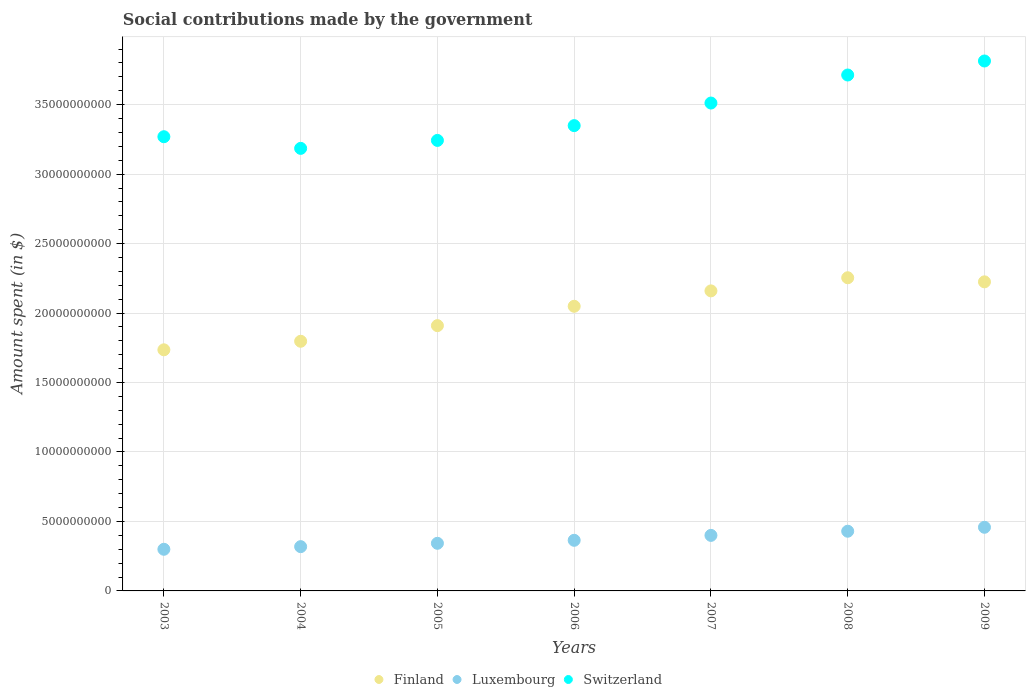What is the amount spent on social contributions in Finland in 2008?
Keep it short and to the point. 2.25e+1. Across all years, what is the maximum amount spent on social contributions in Luxembourg?
Make the answer very short. 4.58e+09. Across all years, what is the minimum amount spent on social contributions in Luxembourg?
Give a very brief answer. 3.00e+09. In which year was the amount spent on social contributions in Switzerland minimum?
Keep it short and to the point. 2004. What is the total amount spent on social contributions in Luxembourg in the graph?
Provide a succinct answer. 2.61e+1. What is the difference between the amount spent on social contributions in Luxembourg in 2004 and that in 2005?
Ensure brevity in your answer.  -2.41e+08. What is the difference between the amount spent on social contributions in Switzerland in 2005 and the amount spent on social contributions in Luxembourg in 2007?
Make the answer very short. 2.84e+1. What is the average amount spent on social contributions in Finland per year?
Your answer should be very brief. 2.02e+1. In the year 2009, what is the difference between the amount spent on social contributions in Switzerland and amount spent on social contributions in Luxembourg?
Provide a short and direct response. 3.36e+1. What is the ratio of the amount spent on social contributions in Switzerland in 2003 to that in 2008?
Keep it short and to the point. 0.88. What is the difference between the highest and the second highest amount spent on social contributions in Luxembourg?
Offer a very short reply. 2.83e+08. What is the difference between the highest and the lowest amount spent on social contributions in Luxembourg?
Make the answer very short. 1.58e+09. In how many years, is the amount spent on social contributions in Finland greater than the average amount spent on social contributions in Finland taken over all years?
Your answer should be very brief. 4. Does the amount spent on social contributions in Finland monotonically increase over the years?
Your response must be concise. No. How many dotlines are there?
Your answer should be compact. 3. What is the difference between two consecutive major ticks on the Y-axis?
Offer a terse response. 5.00e+09. Are the values on the major ticks of Y-axis written in scientific E-notation?
Keep it short and to the point. No. Does the graph contain any zero values?
Give a very brief answer. No. Where does the legend appear in the graph?
Offer a very short reply. Bottom center. How many legend labels are there?
Provide a short and direct response. 3. What is the title of the graph?
Your response must be concise. Social contributions made by the government. Does "Libya" appear as one of the legend labels in the graph?
Make the answer very short. No. What is the label or title of the X-axis?
Your response must be concise. Years. What is the label or title of the Y-axis?
Offer a terse response. Amount spent (in $). What is the Amount spent (in $) in Finland in 2003?
Your response must be concise. 1.74e+1. What is the Amount spent (in $) in Luxembourg in 2003?
Offer a terse response. 3.00e+09. What is the Amount spent (in $) of Switzerland in 2003?
Offer a terse response. 3.27e+1. What is the Amount spent (in $) of Finland in 2004?
Ensure brevity in your answer.  1.80e+1. What is the Amount spent (in $) of Luxembourg in 2004?
Provide a succinct answer. 3.19e+09. What is the Amount spent (in $) of Switzerland in 2004?
Provide a succinct answer. 3.19e+1. What is the Amount spent (in $) in Finland in 2005?
Make the answer very short. 1.91e+1. What is the Amount spent (in $) of Luxembourg in 2005?
Your answer should be very brief. 3.43e+09. What is the Amount spent (in $) of Switzerland in 2005?
Your answer should be compact. 3.24e+1. What is the Amount spent (in $) in Finland in 2006?
Your answer should be very brief. 2.05e+1. What is the Amount spent (in $) of Luxembourg in 2006?
Give a very brief answer. 3.64e+09. What is the Amount spent (in $) in Switzerland in 2006?
Offer a very short reply. 3.35e+1. What is the Amount spent (in $) of Finland in 2007?
Ensure brevity in your answer.  2.16e+1. What is the Amount spent (in $) of Luxembourg in 2007?
Ensure brevity in your answer.  4.00e+09. What is the Amount spent (in $) in Switzerland in 2007?
Ensure brevity in your answer.  3.51e+1. What is the Amount spent (in $) of Finland in 2008?
Provide a short and direct response. 2.25e+1. What is the Amount spent (in $) of Luxembourg in 2008?
Provide a succinct answer. 4.30e+09. What is the Amount spent (in $) in Switzerland in 2008?
Make the answer very short. 3.71e+1. What is the Amount spent (in $) in Finland in 2009?
Your response must be concise. 2.22e+1. What is the Amount spent (in $) of Luxembourg in 2009?
Provide a short and direct response. 4.58e+09. What is the Amount spent (in $) in Switzerland in 2009?
Your response must be concise. 3.81e+1. Across all years, what is the maximum Amount spent (in $) in Finland?
Offer a terse response. 2.25e+1. Across all years, what is the maximum Amount spent (in $) of Luxembourg?
Keep it short and to the point. 4.58e+09. Across all years, what is the maximum Amount spent (in $) of Switzerland?
Offer a terse response. 3.81e+1. Across all years, what is the minimum Amount spent (in $) in Finland?
Provide a short and direct response. 1.74e+1. Across all years, what is the minimum Amount spent (in $) of Luxembourg?
Offer a very short reply. 3.00e+09. Across all years, what is the minimum Amount spent (in $) of Switzerland?
Offer a very short reply. 3.19e+1. What is the total Amount spent (in $) of Finland in the graph?
Keep it short and to the point. 1.41e+11. What is the total Amount spent (in $) in Luxembourg in the graph?
Keep it short and to the point. 2.61e+1. What is the total Amount spent (in $) of Switzerland in the graph?
Give a very brief answer. 2.41e+11. What is the difference between the Amount spent (in $) in Finland in 2003 and that in 2004?
Offer a terse response. -6.15e+08. What is the difference between the Amount spent (in $) in Luxembourg in 2003 and that in 2004?
Your response must be concise. -1.89e+08. What is the difference between the Amount spent (in $) of Switzerland in 2003 and that in 2004?
Your response must be concise. 8.39e+08. What is the difference between the Amount spent (in $) of Finland in 2003 and that in 2005?
Your answer should be very brief. -1.74e+09. What is the difference between the Amount spent (in $) in Luxembourg in 2003 and that in 2005?
Offer a terse response. -4.31e+08. What is the difference between the Amount spent (in $) of Switzerland in 2003 and that in 2005?
Provide a short and direct response. 2.66e+08. What is the difference between the Amount spent (in $) of Finland in 2003 and that in 2006?
Your answer should be very brief. -3.13e+09. What is the difference between the Amount spent (in $) in Luxembourg in 2003 and that in 2006?
Provide a succinct answer. -6.46e+08. What is the difference between the Amount spent (in $) of Switzerland in 2003 and that in 2006?
Provide a succinct answer. -7.99e+08. What is the difference between the Amount spent (in $) in Finland in 2003 and that in 2007?
Make the answer very short. -4.24e+09. What is the difference between the Amount spent (in $) in Luxembourg in 2003 and that in 2007?
Your answer should be compact. -1.00e+09. What is the difference between the Amount spent (in $) in Switzerland in 2003 and that in 2007?
Provide a succinct answer. -2.42e+09. What is the difference between the Amount spent (in $) in Finland in 2003 and that in 2008?
Offer a very short reply. -5.19e+09. What is the difference between the Amount spent (in $) in Luxembourg in 2003 and that in 2008?
Make the answer very short. -1.30e+09. What is the difference between the Amount spent (in $) of Switzerland in 2003 and that in 2008?
Your answer should be very brief. -4.44e+09. What is the difference between the Amount spent (in $) in Finland in 2003 and that in 2009?
Keep it short and to the point. -4.89e+09. What is the difference between the Amount spent (in $) of Luxembourg in 2003 and that in 2009?
Provide a succinct answer. -1.58e+09. What is the difference between the Amount spent (in $) in Switzerland in 2003 and that in 2009?
Give a very brief answer. -5.45e+09. What is the difference between the Amount spent (in $) in Finland in 2004 and that in 2005?
Provide a short and direct response. -1.12e+09. What is the difference between the Amount spent (in $) in Luxembourg in 2004 and that in 2005?
Make the answer very short. -2.41e+08. What is the difference between the Amount spent (in $) in Switzerland in 2004 and that in 2005?
Give a very brief answer. -5.73e+08. What is the difference between the Amount spent (in $) of Finland in 2004 and that in 2006?
Keep it short and to the point. -2.52e+09. What is the difference between the Amount spent (in $) of Luxembourg in 2004 and that in 2006?
Keep it short and to the point. -4.57e+08. What is the difference between the Amount spent (in $) of Switzerland in 2004 and that in 2006?
Offer a very short reply. -1.64e+09. What is the difference between the Amount spent (in $) in Finland in 2004 and that in 2007?
Offer a terse response. -3.63e+09. What is the difference between the Amount spent (in $) in Luxembourg in 2004 and that in 2007?
Your answer should be very brief. -8.11e+08. What is the difference between the Amount spent (in $) of Switzerland in 2004 and that in 2007?
Offer a very short reply. -3.26e+09. What is the difference between the Amount spent (in $) of Finland in 2004 and that in 2008?
Provide a succinct answer. -4.57e+09. What is the difference between the Amount spent (in $) of Luxembourg in 2004 and that in 2008?
Offer a very short reply. -1.11e+09. What is the difference between the Amount spent (in $) of Switzerland in 2004 and that in 2008?
Your answer should be very brief. -5.28e+09. What is the difference between the Amount spent (in $) of Finland in 2004 and that in 2009?
Your answer should be compact. -4.28e+09. What is the difference between the Amount spent (in $) of Luxembourg in 2004 and that in 2009?
Your answer should be compact. -1.39e+09. What is the difference between the Amount spent (in $) of Switzerland in 2004 and that in 2009?
Make the answer very short. -6.29e+09. What is the difference between the Amount spent (in $) of Finland in 2005 and that in 2006?
Make the answer very short. -1.39e+09. What is the difference between the Amount spent (in $) in Luxembourg in 2005 and that in 2006?
Your answer should be very brief. -2.16e+08. What is the difference between the Amount spent (in $) in Switzerland in 2005 and that in 2006?
Give a very brief answer. -1.06e+09. What is the difference between the Amount spent (in $) of Finland in 2005 and that in 2007?
Offer a very short reply. -2.50e+09. What is the difference between the Amount spent (in $) of Luxembourg in 2005 and that in 2007?
Your response must be concise. -5.70e+08. What is the difference between the Amount spent (in $) in Switzerland in 2005 and that in 2007?
Offer a terse response. -2.69e+09. What is the difference between the Amount spent (in $) of Finland in 2005 and that in 2008?
Your answer should be very brief. -3.45e+09. What is the difference between the Amount spent (in $) of Luxembourg in 2005 and that in 2008?
Your answer should be compact. -8.69e+08. What is the difference between the Amount spent (in $) in Switzerland in 2005 and that in 2008?
Your answer should be very brief. -4.71e+09. What is the difference between the Amount spent (in $) of Finland in 2005 and that in 2009?
Provide a succinct answer. -3.15e+09. What is the difference between the Amount spent (in $) in Luxembourg in 2005 and that in 2009?
Provide a short and direct response. -1.15e+09. What is the difference between the Amount spent (in $) in Switzerland in 2005 and that in 2009?
Ensure brevity in your answer.  -5.72e+09. What is the difference between the Amount spent (in $) in Finland in 2006 and that in 2007?
Provide a short and direct response. -1.11e+09. What is the difference between the Amount spent (in $) of Luxembourg in 2006 and that in 2007?
Provide a succinct answer. -3.54e+08. What is the difference between the Amount spent (in $) in Switzerland in 2006 and that in 2007?
Offer a terse response. -1.62e+09. What is the difference between the Amount spent (in $) in Finland in 2006 and that in 2008?
Make the answer very short. -2.05e+09. What is the difference between the Amount spent (in $) of Luxembourg in 2006 and that in 2008?
Your response must be concise. -6.53e+08. What is the difference between the Amount spent (in $) of Switzerland in 2006 and that in 2008?
Make the answer very short. -3.64e+09. What is the difference between the Amount spent (in $) of Finland in 2006 and that in 2009?
Provide a succinct answer. -1.76e+09. What is the difference between the Amount spent (in $) of Luxembourg in 2006 and that in 2009?
Ensure brevity in your answer.  -9.37e+08. What is the difference between the Amount spent (in $) in Switzerland in 2006 and that in 2009?
Offer a terse response. -4.65e+09. What is the difference between the Amount spent (in $) in Finland in 2007 and that in 2008?
Offer a terse response. -9.45e+08. What is the difference between the Amount spent (in $) of Luxembourg in 2007 and that in 2008?
Offer a very short reply. -2.99e+08. What is the difference between the Amount spent (in $) in Switzerland in 2007 and that in 2008?
Offer a very short reply. -2.02e+09. What is the difference between the Amount spent (in $) in Finland in 2007 and that in 2009?
Offer a very short reply. -6.51e+08. What is the difference between the Amount spent (in $) of Luxembourg in 2007 and that in 2009?
Provide a succinct answer. -5.83e+08. What is the difference between the Amount spent (in $) of Switzerland in 2007 and that in 2009?
Provide a short and direct response. -3.03e+09. What is the difference between the Amount spent (in $) in Finland in 2008 and that in 2009?
Your answer should be very brief. 2.94e+08. What is the difference between the Amount spent (in $) of Luxembourg in 2008 and that in 2009?
Provide a succinct answer. -2.83e+08. What is the difference between the Amount spent (in $) in Switzerland in 2008 and that in 2009?
Offer a very short reply. -1.01e+09. What is the difference between the Amount spent (in $) in Finland in 2003 and the Amount spent (in $) in Luxembourg in 2004?
Provide a short and direct response. 1.42e+1. What is the difference between the Amount spent (in $) in Finland in 2003 and the Amount spent (in $) in Switzerland in 2004?
Offer a terse response. -1.45e+1. What is the difference between the Amount spent (in $) in Luxembourg in 2003 and the Amount spent (in $) in Switzerland in 2004?
Offer a very short reply. -2.89e+1. What is the difference between the Amount spent (in $) of Finland in 2003 and the Amount spent (in $) of Luxembourg in 2005?
Make the answer very short. 1.39e+1. What is the difference between the Amount spent (in $) of Finland in 2003 and the Amount spent (in $) of Switzerland in 2005?
Your answer should be very brief. -1.51e+1. What is the difference between the Amount spent (in $) of Luxembourg in 2003 and the Amount spent (in $) of Switzerland in 2005?
Your response must be concise. -2.94e+1. What is the difference between the Amount spent (in $) in Finland in 2003 and the Amount spent (in $) in Luxembourg in 2006?
Your answer should be compact. 1.37e+1. What is the difference between the Amount spent (in $) in Finland in 2003 and the Amount spent (in $) in Switzerland in 2006?
Make the answer very short. -1.61e+1. What is the difference between the Amount spent (in $) in Luxembourg in 2003 and the Amount spent (in $) in Switzerland in 2006?
Your answer should be compact. -3.05e+1. What is the difference between the Amount spent (in $) in Finland in 2003 and the Amount spent (in $) in Luxembourg in 2007?
Provide a succinct answer. 1.34e+1. What is the difference between the Amount spent (in $) of Finland in 2003 and the Amount spent (in $) of Switzerland in 2007?
Give a very brief answer. -1.78e+1. What is the difference between the Amount spent (in $) in Luxembourg in 2003 and the Amount spent (in $) in Switzerland in 2007?
Provide a succinct answer. -3.21e+1. What is the difference between the Amount spent (in $) of Finland in 2003 and the Amount spent (in $) of Luxembourg in 2008?
Give a very brief answer. 1.31e+1. What is the difference between the Amount spent (in $) in Finland in 2003 and the Amount spent (in $) in Switzerland in 2008?
Offer a very short reply. -1.98e+1. What is the difference between the Amount spent (in $) of Luxembourg in 2003 and the Amount spent (in $) of Switzerland in 2008?
Provide a succinct answer. -3.41e+1. What is the difference between the Amount spent (in $) of Finland in 2003 and the Amount spent (in $) of Luxembourg in 2009?
Give a very brief answer. 1.28e+1. What is the difference between the Amount spent (in $) in Finland in 2003 and the Amount spent (in $) in Switzerland in 2009?
Make the answer very short. -2.08e+1. What is the difference between the Amount spent (in $) in Luxembourg in 2003 and the Amount spent (in $) in Switzerland in 2009?
Offer a very short reply. -3.51e+1. What is the difference between the Amount spent (in $) in Finland in 2004 and the Amount spent (in $) in Luxembourg in 2005?
Offer a very short reply. 1.45e+1. What is the difference between the Amount spent (in $) in Finland in 2004 and the Amount spent (in $) in Switzerland in 2005?
Make the answer very short. -1.45e+1. What is the difference between the Amount spent (in $) in Luxembourg in 2004 and the Amount spent (in $) in Switzerland in 2005?
Give a very brief answer. -2.92e+1. What is the difference between the Amount spent (in $) in Finland in 2004 and the Amount spent (in $) in Luxembourg in 2006?
Give a very brief answer. 1.43e+1. What is the difference between the Amount spent (in $) of Finland in 2004 and the Amount spent (in $) of Switzerland in 2006?
Offer a terse response. -1.55e+1. What is the difference between the Amount spent (in $) in Luxembourg in 2004 and the Amount spent (in $) in Switzerland in 2006?
Your answer should be compact. -3.03e+1. What is the difference between the Amount spent (in $) of Finland in 2004 and the Amount spent (in $) of Luxembourg in 2007?
Keep it short and to the point. 1.40e+1. What is the difference between the Amount spent (in $) in Finland in 2004 and the Amount spent (in $) in Switzerland in 2007?
Keep it short and to the point. -1.71e+1. What is the difference between the Amount spent (in $) in Luxembourg in 2004 and the Amount spent (in $) in Switzerland in 2007?
Provide a short and direct response. -3.19e+1. What is the difference between the Amount spent (in $) in Finland in 2004 and the Amount spent (in $) in Luxembourg in 2008?
Your response must be concise. 1.37e+1. What is the difference between the Amount spent (in $) in Finland in 2004 and the Amount spent (in $) in Switzerland in 2008?
Offer a very short reply. -1.92e+1. What is the difference between the Amount spent (in $) in Luxembourg in 2004 and the Amount spent (in $) in Switzerland in 2008?
Your answer should be compact. -3.39e+1. What is the difference between the Amount spent (in $) in Finland in 2004 and the Amount spent (in $) in Luxembourg in 2009?
Provide a short and direct response. 1.34e+1. What is the difference between the Amount spent (in $) in Finland in 2004 and the Amount spent (in $) in Switzerland in 2009?
Your answer should be very brief. -2.02e+1. What is the difference between the Amount spent (in $) of Luxembourg in 2004 and the Amount spent (in $) of Switzerland in 2009?
Provide a succinct answer. -3.50e+1. What is the difference between the Amount spent (in $) of Finland in 2005 and the Amount spent (in $) of Luxembourg in 2006?
Keep it short and to the point. 1.55e+1. What is the difference between the Amount spent (in $) in Finland in 2005 and the Amount spent (in $) in Switzerland in 2006?
Make the answer very short. -1.44e+1. What is the difference between the Amount spent (in $) of Luxembourg in 2005 and the Amount spent (in $) of Switzerland in 2006?
Your response must be concise. -3.01e+1. What is the difference between the Amount spent (in $) in Finland in 2005 and the Amount spent (in $) in Luxembourg in 2007?
Your answer should be compact. 1.51e+1. What is the difference between the Amount spent (in $) in Finland in 2005 and the Amount spent (in $) in Switzerland in 2007?
Your answer should be very brief. -1.60e+1. What is the difference between the Amount spent (in $) of Luxembourg in 2005 and the Amount spent (in $) of Switzerland in 2007?
Provide a succinct answer. -3.17e+1. What is the difference between the Amount spent (in $) in Finland in 2005 and the Amount spent (in $) in Luxembourg in 2008?
Keep it short and to the point. 1.48e+1. What is the difference between the Amount spent (in $) in Finland in 2005 and the Amount spent (in $) in Switzerland in 2008?
Provide a short and direct response. -1.80e+1. What is the difference between the Amount spent (in $) of Luxembourg in 2005 and the Amount spent (in $) of Switzerland in 2008?
Your answer should be very brief. -3.37e+1. What is the difference between the Amount spent (in $) in Finland in 2005 and the Amount spent (in $) in Luxembourg in 2009?
Your response must be concise. 1.45e+1. What is the difference between the Amount spent (in $) of Finland in 2005 and the Amount spent (in $) of Switzerland in 2009?
Keep it short and to the point. -1.90e+1. What is the difference between the Amount spent (in $) of Luxembourg in 2005 and the Amount spent (in $) of Switzerland in 2009?
Keep it short and to the point. -3.47e+1. What is the difference between the Amount spent (in $) in Finland in 2006 and the Amount spent (in $) in Luxembourg in 2007?
Offer a very short reply. 1.65e+1. What is the difference between the Amount spent (in $) of Finland in 2006 and the Amount spent (in $) of Switzerland in 2007?
Your answer should be very brief. -1.46e+1. What is the difference between the Amount spent (in $) of Luxembourg in 2006 and the Amount spent (in $) of Switzerland in 2007?
Ensure brevity in your answer.  -3.15e+1. What is the difference between the Amount spent (in $) of Finland in 2006 and the Amount spent (in $) of Luxembourg in 2008?
Give a very brief answer. 1.62e+1. What is the difference between the Amount spent (in $) in Finland in 2006 and the Amount spent (in $) in Switzerland in 2008?
Your answer should be compact. -1.66e+1. What is the difference between the Amount spent (in $) of Luxembourg in 2006 and the Amount spent (in $) of Switzerland in 2008?
Offer a terse response. -3.35e+1. What is the difference between the Amount spent (in $) of Finland in 2006 and the Amount spent (in $) of Luxembourg in 2009?
Give a very brief answer. 1.59e+1. What is the difference between the Amount spent (in $) of Finland in 2006 and the Amount spent (in $) of Switzerland in 2009?
Provide a short and direct response. -1.77e+1. What is the difference between the Amount spent (in $) of Luxembourg in 2006 and the Amount spent (in $) of Switzerland in 2009?
Give a very brief answer. -3.45e+1. What is the difference between the Amount spent (in $) of Finland in 2007 and the Amount spent (in $) of Luxembourg in 2008?
Your response must be concise. 1.73e+1. What is the difference between the Amount spent (in $) in Finland in 2007 and the Amount spent (in $) in Switzerland in 2008?
Offer a very short reply. -1.55e+1. What is the difference between the Amount spent (in $) in Luxembourg in 2007 and the Amount spent (in $) in Switzerland in 2008?
Keep it short and to the point. -3.31e+1. What is the difference between the Amount spent (in $) of Finland in 2007 and the Amount spent (in $) of Luxembourg in 2009?
Offer a very short reply. 1.70e+1. What is the difference between the Amount spent (in $) of Finland in 2007 and the Amount spent (in $) of Switzerland in 2009?
Your response must be concise. -1.65e+1. What is the difference between the Amount spent (in $) of Luxembourg in 2007 and the Amount spent (in $) of Switzerland in 2009?
Give a very brief answer. -3.41e+1. What is the difference between the Amount spent (in $) in Finland in 2008 and the Amount spent (in $) in Luxembourg in 2009?
Your answer should be compact. 1.80e+1. What is the difference between the Amount spent (in $) in Finland in 2008 and the Amount spent (in $) in Switzerland in 2009?
Provide a succinct answer. -1.56e+1. What is the difference between the Amount spent (in $) in Luxembourg in 2008 and the Amount spent (in $) in Switzerland in 2009?
Provide a short and direct response. -3.38e+1. What is the average Amount spent (in $) in Finland per year?
Make the answer very short. 2.02e+1. What is the average Amount spent (in $) of Luxembourg per year?
Provide a succinct answer. 3.73e+09. What is the average Amount spent (in $) of Switzerland per year?
Provide a short and direct response. 3.44e+1. In the year 2003, what is the difference between the Amount spent (in $) of Finland and Amount spent (in $) of Luxembourg?
Offer a very short reply. 1.44e+1. In the year 2003, what is the difference between the Amount spent (in $) of Finland and Amount spent (in $) of Switzerland?
Your answer should be very brief. -1.53e+1. In the year 2003, what is the difference between the Amount spent (in $) in Luxembourg and Amount spent (in $) in Switzerland?
Give a very brief answer. -2.97e+1. In the year 2004, what is the difference between the Amount spent (in $) of Finland and Amount spent (in $) of Luxembourg?
Offer a very short reply. 1.48e+1. In the year 2004, what is the difference between the Amount spent (in $) in Finland and Amount spent (in $) in Switzerland?
Make the answer very short. -1.39e+1. In the year 2004, what is the difference between the Amount spent (in $) in Luxembourg and Amount spent (in $) in Switzerland?
Keep it short and to the point. -2.87e+1. In the year 2005, what is the difference between the Amount spent (in $) of Finland and Amount spent (in $) of Luxembourg?
Keep it short and to the point. 1.57e+1. In the year 2005, what is the difference between the Amount spent (in $) of Finland and Amount spent (in $) of Switzerland?
Your answer should be very brief. -1.33e+1. In the year 2005, what is the difference between the Amount spent (in $) of Luxembourg and Amount spent (in $) of Switzerland?
Your answer should be very brief. -2.90e+1. In the year 2006, what is the difference between the Amount spent (in $) in Finland and Amount spent (in $) in Luxembourg?
Provide a succinct answer. 1.68e+1. In the year 2006, what is the difference between the Amount spent (in $) of Finland and Amount spent (in $) of Switzerland?
Offer a terse response. -1.30e+1. In the year 2006, what is the difference between the Amount spent (in $) in Luxembourg and Amount spent (in $) in Switzerland?
Make the answer very short. -2.98e+1. In the year 2007, what is the difference between the Amount spent (in $) of Finland and Amount spent (in $) of Luxembourg?
Provide a short and direct response. 1.76e+1. In the year 2007, what is the difference between the Amount spent (in $) of Finland and Amount spent (in $) of Switzerland?
Ensure brevity in your answer.  -1.35e+1. In the year 2007, what is the difference between the Amount spent (in $) of Luxembourg and Amount spent (in $) of Switzerland?
Ensure brevity in your answer.  -3.11e+1. In the year 2008, what is the difference between the Amount spent (in $) in Finland and Amount spent (in $) in Luxembourg?
Make the answer very short. 1.82e+1. In the year 2008, what is the difference between the Amount spent (in $) of Finland and Amount spent (in $) of Switzerland?
Your answer should be compact. -1.46e+1. In the year 2008, what is the difference between the Amount spent (in $) in Luxembourg and Amount spent (in $) in Switzerland?
Offer a very short reply. -3.28e+1. In the year 2009, what is the difference between the Amount spent (in $) in Finland and Amount spent (in $) in Luxembourg?
Provide a succinct answer. 1.77e+1. In the year 2009, what is the difference between the Amount spent (in $) in Finland and Amount spent (in $) in Switzerland?
Your response must be concise. -1.59e+1. In the year 2009, what is the difference between the Amount spent (in $) in Luxembourg and Amount spent (in $) in Switzerland?
Give a very brief answer. -3.36e+1. What is the ratio of the Amount spent (in $) of Finland in 2003 to that in 2004?
Provide a succinct answer. 0.97. What is the ratio of the Amount spent (in $) in Luxembourg in 2003 to that in 2004?
Make the answer very short. 0.94. What is the ratio of the Amount spent (in $) in Switzerland in 2003 to that in 2004?
Offer a very short reply. 1.03. What is the ratio of the Amount spent (in $) in Finland in 2003 to that in 2005?
Give a very brief answer. 0.91. What is the ratio of the Amount spent (in $) in Luxembourg in 2003 to that in 2005?
Offer a terse response. 0.87. What is the ratio of the Amount spent (in $) of Switzerland in 2003 to that in 2005?
Your answer should be compact. 1.01. What is the ratio of the Amount spent (in $) of Finland in 2003 to that in 2006?
Provide a succinct answer. 0.85. What is the ratio of the Amount spent (in $) of Luxembourg in 2003 to that in 2006?
Offer a very short reply. 0.82. What is the ratio of the Amount spent (in $) of Switzerland in 2003 to that in 2006?
Your response must be concise. 0.98. What is the ratio of the Amount spent (in $) of Finland in 2003 to that in 2007?
Your answer should be very brief. 0.8. What is the ratio of the Amount spent (in $) in Luxembourg in 2003 to that in 2007?
Offer a very short reply. 0.75. What is the ratio of the Amount spent (in $) of Switzerland in 2003 to that in 2007?
Your answer should be very brief. 0.93. What is the ratio of the Amount spent (in $) in Finland in 2003 to that in 2008?
Your answer should be very brief. 0.77. What is the ratio of the Amount spent (in $) in Luxembourg in 2003 to that in 2008?
Your response must be concise. 0.7. What is the ratio of the Amount spent (in $) in Switzerland in 2003 to that in 2008?
Make the answer very short. 0.88. What is the ratio of the Amount spent (in $) of Finland in 2003 to that in 2009?
Ensure brevity in your answer.  0.78. What is the ratio of the Amount spent (in $) of Luxembourg in 2003 to that in 2009?
Make the answer very short. 0.65. What is the ratio of the Amount spent (in $) in Switzerland in 2003 to that in 2009?
Offer a very short reply. 0.86. What is the ratio of the Amount spent (in $) of Finland in 2004 to that in 2005?
Provide a succinct answer. 0.94. What is the ratio of the Amount spent (in $) in Luxembourg in 2004 to that in 2005?
Your response must be concise. 0.93. What is the ratio of the Amount spent (in $) of Switzerland in 2004 to that in 2005?
Provide a short and direct response. 0.98. What is the ratio of the Amount spent (in $) in Finland in 2004 to that in 2006?
Your answer should be compact. 0.88. What is the ratio of the Amount spent (in $) in Luxembourg in 2004 to that in 2006?
Provide a succinct answer. 0.87. What is the ratio of the Amount spent (in $) in Switzerland in 2004 to that in 2006?
Offer a terse response. 0.95. What is the ratio of the Amount spent (in $) of Finland in 2004 to that in 2007?
Make the answer very short. 0.83. What is the ratio of the Amount spent (in $) in Luxembourg in 2004 to that in 2007?
Offer a very short reply. 0.8. What is the ratio of the Amount spent (in $) in Switzerland in 2004 to that in 2007?
Provide a short and direct response. 0.91. What is the ratio of the Amount spent (in $) in Finland in 2004 to that in 2008?
Give a very brief answer. 0.8. What is the ratio of the Amount spent (in $) in Luxembourg in 2004 to that in 2008?
Offer a terse response. 0.74. What is the ratio of the Amount spent (in $) in Switzerland in 2004 to that in 2008?
Provide a short and direct response. 0.86. What is the ratio of the Amount spent (in $) in Finland in 2004 to that in 2009?
Give a very brief answer. 0.81. What is the ratio of the Amount spent (in $) in Luxembourg in 2004 to that in 2009?
Offer a very short reply. 0.7. What is the ratio of the Amount spent (in $) of Switzerland in 2004 to that in 2009?
Ensure brevity in your answer.  0.84. What is the ratio of the Amount spent (in $) in Finland in 2005 to that in 2006?
Offer a very short reply. 0.93. What is the ratio of the Amount spent (in $) in Luxembourg in 2005 to that in 2006?
Provide a succinct answer. 0.94. What is the ratio of the Amount spent (in $) in Switzerland in 2005 to that in 2006?
Give a very brief answer. 0.97. What is the ratio of the Amount spent (in $) in Finland in 2005 to that in 2007?
Your answer should be compact. 0.88. What is the ratio of the Amount spent (in $) in Luxembourg in 2005 to that in 2007?
Provide a succinct answer. 0.86. What is the ratio of the Amount spent (in $) in Switzerland in 2005 to that in 2007?
Give a very brief answer. 0.92. What is the ratio of the Amount spent (in $) in Finland in 2005 to that in 2008?
Offer a very short reply. 0.85. What is the ratio of the Amount spent (in $) in Luxembourg in 2005 to that in 2008?
Give a very brief answer. 0.8. What is the ratio of the Amount spent (in $) in Switzerland in 2005 to that in 2008?
Make the answer very short. 0.87. What is the ratio of the Amount spent (in $) of Finland in 2005 to that in 2009?
Ensure brevity in your answer.  0.86. What is the ratio of the Amount spent (in $) of Luxembourg in 2005 to that in 2009?
Keep it short and to the point. 0.75. What is the ratio of the Amount spent (in $) of Switzerland in 2005 to that in 2009?
Keep it short and to the point. 0.85. What is the ratio of the Amount spent (in $) in Finland in 2006 to that in 2007?
Offer a terse response. 0.95. What is the ratio of the Amount spent (in $) in Luxembourg in 2006 to that in 2007?
Give a very brief answer. 0.91. What is the ratio of the Amount spent (in $) in Switzerland in 2006 to that in 2007?
Ensure brevity in your answer.  0.95. What is the ratio of the Amount spent (in $) of Finland in 2006 to that in 2008?
Your answer should be very brief. 0.91. What is the ratio of the Amount spent (in $) in Luxembourg in 2006 to that in 2008?
Make the answer very short. 0.85. What is the ratio of the Amount spent (in $) in Switzerland in 2006 to that in 2008?
Your answer should be compact. 0.9. What is the ratio of the Amount spent (in $) of Finland in 2006 to that in 2009?
Keep it short and to the point. 0.92. What is the ratio of the Amount spent (in $) in Luxembourg in 2006 to that in 2009?
Keep it short and to the point. 0.8. What is the ratio of the Amount spent (in $) in Switzerland in 2006 to that in 2009?
Give a very brief answer. 0.88. What is the ratio of the Amount spent (in $) of Finland in 2007 to that in 2008?
Give a very brief answer. 0.96. What is the ratio of the Amount spent (in $) of Luxembourg in 2007 to that in 2008?
Keep it short and to the point. 0.93. What is the ratio of the Amount spent (in $) of Switzerland in 2007 to that in 2008?
Your answer should be very brief. 0.95. What is the ratio of the Amount spent (in $) of Finland in 2007 to that in 2009?
Ensure brevity in your answer.  0.97. What is the ratio of the Amount spent (in $) in Luxembourg in 2007 to that in 2009?
Your response must be concise. 0.87. What is the ratio of the Amount spent (in $) of Switzerland in 2007 to that in 2009?
Your answer should be compact. 0.92. What is the ratio of the Amount spent (in $) in Finland in 2008 to that in 2009?
Your answer should be very brief. 1.01. What is the ratio of the Amount spent (in $) of Luxembourg in 2008 to that in 2009?
Your response must be concise. 0.94. What is the ratio of the Amount spent (in $) of Switzerland in 2008 to that in 2009?
Your response must be concise. 0.97. What is the difference between the highest and the second highest Amount spent (in $) of Finland?
Your answer should be very brief. 2.94e+08. What is the difference between the highest and the second highest Amount spent (in $) in Luxembourg?
Offer a terse response. 2.83e+08. What is the difference between the highest and the second highest Amount spent (in $) of Switzerland?
Offer a terse response. 1.01e+09. What is the difference between the highest and the lowest Amount spent (in $) of Finland?
Your answer should be compact. 5.19e+09. What is the difference between the highest and the lowest Amount spent (in $) in Luxembourg?
Keep it short and to the point. 1.58e+09. What is the difference between the highest and the lowest Amount spent (in $) of Switzerland?
Provide a short and direct response. 6.29e+09. 